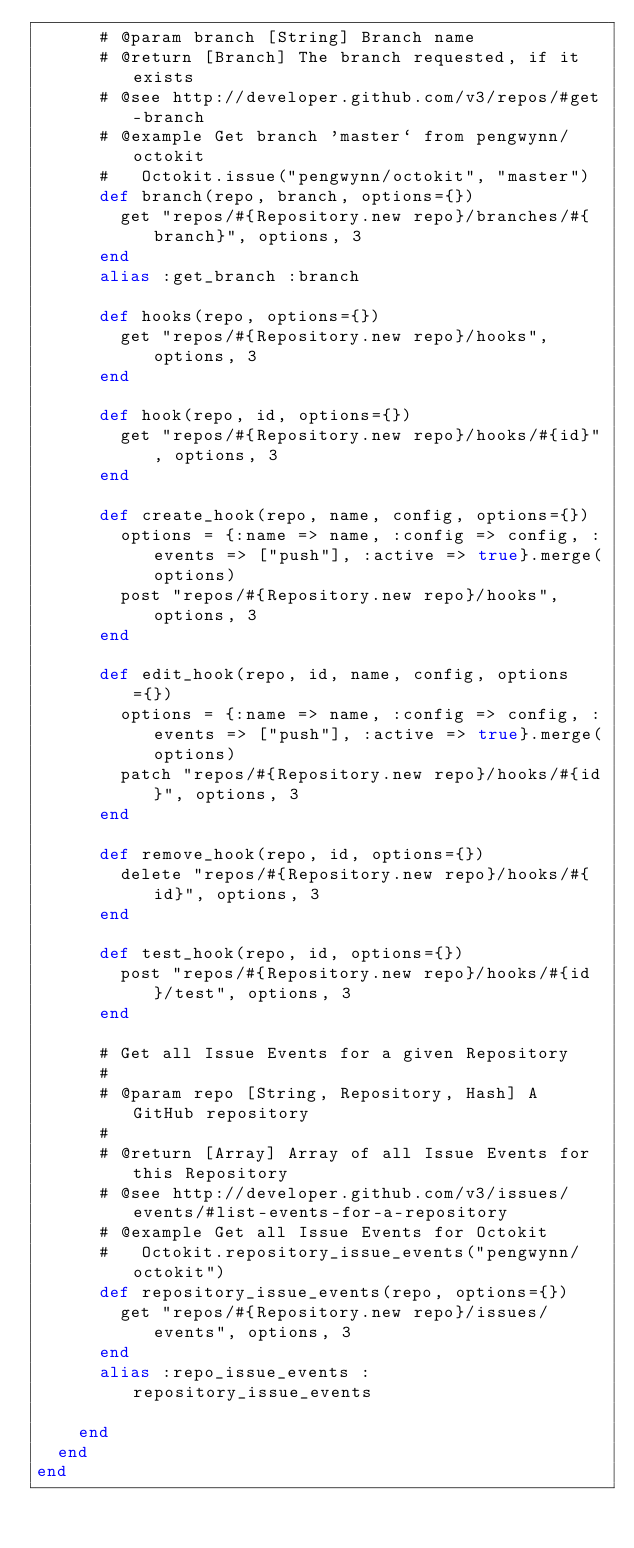<code> <loc_0><loc_0><loc_500><loc_500><_Ruby_>      # @param branch [String] Branch name
      # @return [Branch] The branch requested, if it exists
      # @see http://developer.github.com/v3/repos/#get-branch
      # @example Get branch 'master` from pengwynn/octokit
      #   Octokit.issue("pengwynn/octokit", "master")
      def branch(repo, branch, options={})
        get "repos/#{Repository.new repo}/branches/#{branch}", options, 3
      end
      alias :get_branch :branch

      def hooks(repo, options={})
        get "repos/#{Repository.new repo}/hooks", options, 3
      end

      def hook(repo, id, options={})
        get "repos/#{Repository.new repo}/hooks/#{id}", options, 3
      end

      def create_hook(repo, name, config, options={})
        options = {:name => name, :config => config, :events => ["push"], :active => true}.merge(options)
        post "repos/#{Repository.new repo}/hooks", options, 3
      end

      def edit_hook(repo, id, name, config, options={})
        options = {:name => name, :config => config, :events => ["push"], :active => true}.merge(options)
        patch "repos/#{Repository.new repo}/hooks/#{id}", options, 3
      end

      def remove_hook(repo, id, options={})
        delete "repos/#{Repository.new repo}/hooks/#{id}", options, 3
      end

      def test_hook(repo, id, options={})
        post "repos/#{Repository.new repo}/hooks/#{id}/test", options, 3
      end

      # Get all Issue Events for a given Repository
      #
      # @param repo [String, Repository, Hash] A GitHub repository
      #
      # @return [Array] Array of all Issue Events for this Repository
      # @see http://developer.github.com/v3/issues/events/#list-events-for-a-repository
      # @example Get all Issue Events for Octokit
      #   Octokit.repository_issue_events("pengwynn/octokit")
      def repository_issue_events(repo, options={})
        get "repos/#{Repository.new repo}/issues/events", options, 3
      end
      alias :repo_issue_events :repository_issue_events

    end
  end
end
</code> 